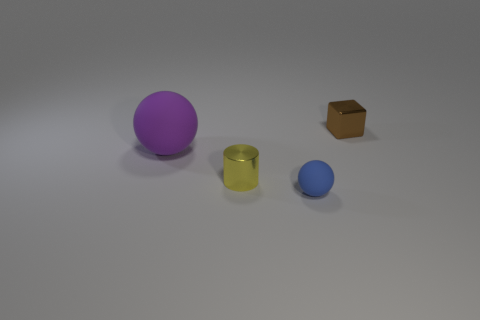Is there anything else that is the same size as the purple rubber object?
Keep it short and to the point. No. There is a metallic object that is behind the metallic object that is in front of the brown metal object; what is its size?
Your answer should be compact. Small. What color is the thing that is in front of the yellow cylinder?
Provide a succinct answer. Blue. Are there any yellow things that have the same shape as the brown shiny object?
Provide a short and direct response. No. Are there fewer big objects right of the small yellow shiny cylinder than shiny cubes to the right of the metal cube?
Your answer should be compact. No. What color is the small rubber object?
Make the answer very short. Blue. Are there any small metal cubes that are to the left of the rubber ball in front of the purple object?
Your response must be concise. No. How many other purple things have the same size as the purple rubber thing?
Keep it short and to the point. 0. There is a sphere on the left side of the tiny thing that is in front of the small yellow object; how many large things are behind it?
Offer a terse response. 0. What number of metallic things are both behind the large thing and on the left side of the block?
Offer a terse response. 0. 